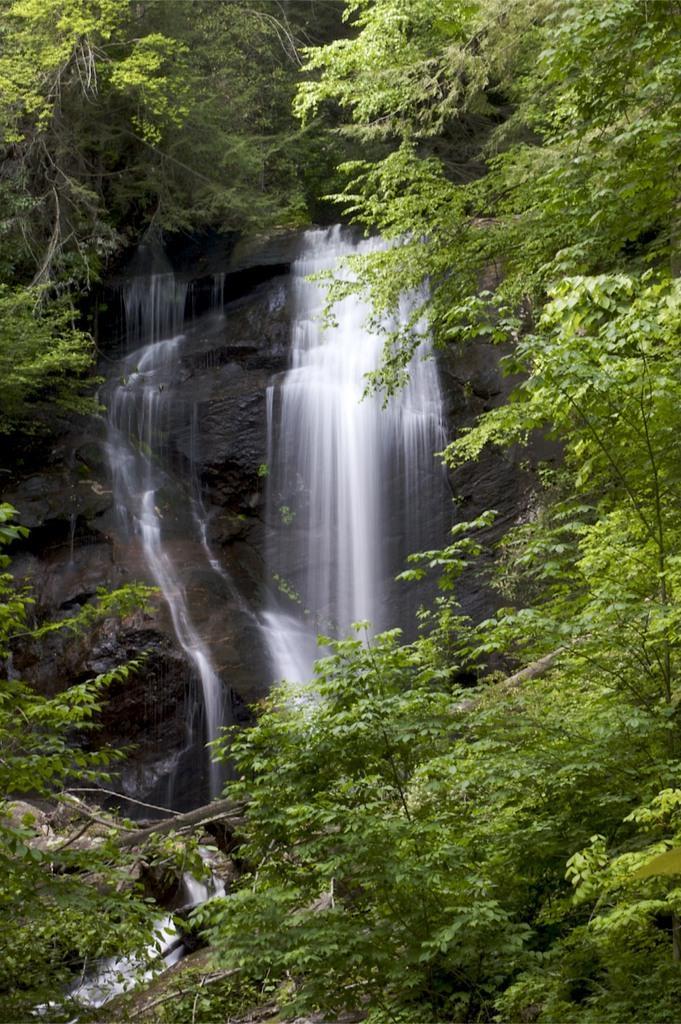Could you give a brief overview of what you see in this image? In this picture we can see the water fall in the middle of the image, surrounded with many trees. 